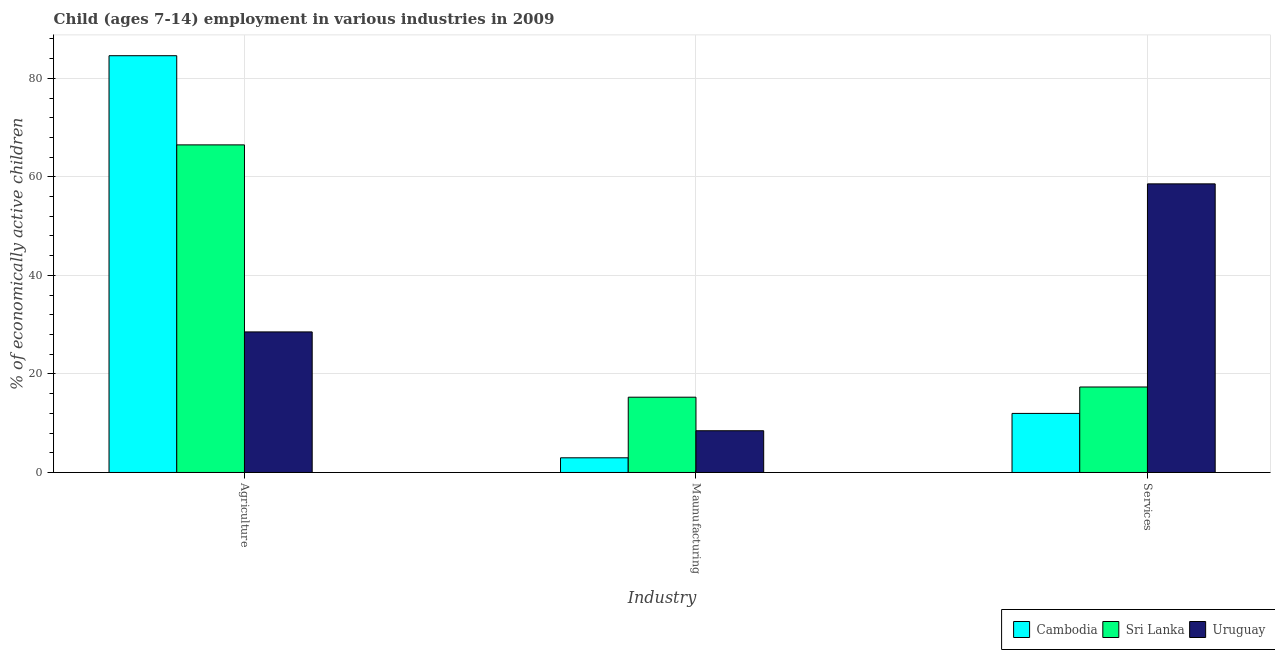How many different coloured bars are there?
Provide a succinct answer. 3. How many groups of bars are there?
Your response must be concise. 3. Are the number of bars per tick equal to the number of legend labels?
Your answer should be compact. Yes. What is the label of the 1st group of bars from the left?
Offer a terse response. Agriculture. What is the percentage of economically active children in agriculture in Cambodia?
Give a very brief answer. 84.59. Across all countries, what is the maximum percentage of economically active children in agriculture?
Your response must be concise. 84.59. Across all countries, what is the minimum percentage of economically active children in agriculture?
Provide a short and direct response. 28.53. In which country was the percentage of economically active children in agriculture maximum?
Make the answer very short. Cambodia. In which country was the percentage of economically active children in manufacturing minimum?
Provide a succinct answer. Cambodia. What is the total percentage of economically active children in manufacturing in the graph?
Your answer should be very brief. 26.73. What is the difference between the percentage of economically active children in manufacturing in Cambodia and that in Uruguay?
Your answer should be compact. -5.49. What is the difference between the percentage of economically active children in agriculture in Uruguay and the percentage of economically active children in services in Sri Lanka?
Keep it short and to the point. 11.18. What is the average percentage of economically active children in manufacturing per country?
Make the answer very short. 8.91. What is the difference between the percentage of economically active children in manufacturing and percentage of economically active children in services in Cambodia?
Your answer should be very brief. -9.01. In how many countries, is the percentage of economically active children in agriculture greater than 60 %?
Offer a terse response. 2. What is the ratio of the percentage of economically active children in services in Uruguay to that in Sri Lanka?
Make the answer very short. 3.38. What is the difference between the highest and the second highest percentage of economically active children in manufacturing?
Provide a succinct answer. 6.81. What is the difference between the highest and the lowest percentage of economically active children in services?
Give a very brief answer. 46.59. In how many countries, is the percentage of economically active children in manufacturing greater than the average percentage of economically active children in manufacturing taken over all countries?
Provide a short and direct response. 1. Is the sum of the percentage of economically active children in agriculture in Uruguay and Sri Lanka greater than the maximum percentage of economically active children in services across all countries?
Your answer should be very brief. Yes. What does the 2nd bar from the left in Services represents?
Your answer should be very brief. Sri Lanka. What does the 3rd bar from the right in Agriculture represents?
Make the answer very short. Cambodia. How many bars are there?
Offer a terse response. 9. Are all the bars in the graph horizontal?
Provide a short and direct response. No. How many countries are there in the graph?
Provide a short and direct response. 3. What is the difference between two consecutive major ticks on the Y-axis?
Ensure brevity in your answer.  20. How are the legend labels stacked?
Offer a terse response. Horizontal. What is the title of the graph?
Give a very brief answer. Child (ages 7-14) employment in various industries in 2009. What is the label or title of the X-axis?
Your response must be concise. Industry. What is the label or title of the Y-axis?
Your answer should be compact. % of economically active children. What is the % of economically active children in Cambodia in Agriculture?
Ensure brevity in your answer.  84.59. What is the % of economically active children of Sri Lanka in Agriculture?
Provide a short and direct response. 66.49. What is the % of economically active children of Uruguay in Agriculture?
Make the answer very short. 28.53. What is the % of economically active children in Cambodia in Maunufacturing?
Keep it short and to the point. 2.98. What is the % of economically active children in Sri Lanka in Maunufacturing?
Give a very brief answer. 15.28. What is the % of economically active children in Uruguay in Maunufacturing?
Make the answer very short. 8.47. What is the % of economically active children in Cambodia in Services?
Provide a succinct answer. 11.99. What is the % of economically active children in Sri Lanka in Services?
Keep it short and to the point. 17.35. What is the % of economically active children in Uruguay in Services?
Your answer should be compact. 58.58. Across all Industry, what is the maximum % of economically active children of Cambodia?
Keep it short and to the point. 84.59. Across all Industry, what is the maximum % of economically active children in Sri Lanka?
Your answer should be compact. 66.49. Across all Industry, what is the maximum % of economically active children in Uruguay?
Your answer should be very brief. 58.58. Across all Industry, what is the minimum % of economically active children of Cambodia?
Your answer should be compact. 2.98. Across all Industry, what is the minimum % of economically active children of Sri Lanka?
Your answer should be very brief. 15.28. Across all Industry, what is the minimum % of economically active children in Uruguay?
Your response must be concise. 8.47. What is the total % of economically active children in Cambodia in the graph?
Keep it short and to the point. 99.56. What is the total % of economically active children of Sri Lanka in the graph?
Keep it short and to the point. 99.12. What is the total % of economically active children in Uruguay in the graph?
Keep it short and to the point. 95.58. What is the difference between the % of economically active children in Cambodia in Agriculture and that in Maunufacturing?
Ensure brevity in your answer.  81.61. What is the difference between the % of economically active children of Sri Lanka in Agriculture and that in Maunufacturing?
Offer a very short reply. 51.21. What is the difference between the % of economically active children in Uruguay in Agriculture and that in Maunufacturing?
Provide a short and direct response. 20.06. What is the difference between the % of economically active children of Cambodia in Agriculture and that in Services?
Your answer should be very brief. 72.6. What is the difference between the % of economically active children of Sri Lanka in Agriculture and that in Services?
Ensure brevity in your answer.  49.14. What is the difference between the % of economically active children of Uruguay in Agriculture and that in Services?
Your answer should be very brief. -30.05. What is the difference between the % of economically active children in Cambodia in Maunufacturing and that in Services?
Provide a succinct answer. -9.01. What is the difference between the % of economically active children of Sri Lanka in Maunufacturing and that in Services?
Give a very brief answer. -2.07. What is the difference between the % of economically active children of Uruguay in Maunufacturing and that in Services?
Ensure brevity in your answer.  -50.11. What is the difference between the % of economically active children of Cambodia in Agriculture and the % of economically active children of Sri Lanka in Maunufacturing?
Make the answer very short. 69.31. What is the difference between the % of economically active children in Cambodia in Agriculture and the % of economically active children in Uruguay in Maunufacturing?
Your response must be concise. 76.12. What is the difference between the % of economically active children of Sri Lanka in Agriculture and the % of economically active children of Uruguay in Maunufacturing?
Offer a very short reply. 58.02. What is the difference between the % of economically active children of Cambodia in Agriculture and the % of economically active children of Sri Lanka in Services?
Your answer should be very brief. 67.24. What is the difference between the % of economically active children of Cambodia in Agriculture and the % of economically active children of Uruguay in Services?
Your response must be concise. 26.01. What is the difference between the % of economically active children of Sri Lanka in Agriculture and the % of economically active children of Uruguay in Services?
Your response must be concise. 7.91. What is the difference between the % of economically active children in Cambodia in Maunufacturing and the % of economically active children in Sri Lanka in Services?
Ensure brevity in your answer.  -14.37. What is the difference between the % of economically active children in Cambodia in Maunufacturing and the % of economically active children in Uruguay in Services?
Keep it short and to the point. -55.6. What is the difference between the % of economically active children of Sri Lanka in Maunufacturing and the % of economically active children of Uruguay in Services?
Ensure brevity in your answer.  -43.3. What is the average % of economically active children of Cambodia per Industry?
Your answer should be very brief. 33.19. What is the average % of economically active children of Sri Lanka per Industry?
Your response must be concise. 33.04. What is the average % of economically active children in Uruguay per Industry?
Give a very brief answer. 31.86. What is the difference between the % of economically active children of Cambodia and % of economically active children of Sri Lanka in Agriculture?
Your answer should be compact. 18.1. What is the difference between the % of economically active children in Cambodia and % of economically active children in Uruguay in Agriculture?
Keep it short and to the point. 56.06. What is the difference between the % of economically active children of Sri Lanka and % of economically active children of Uruguay in Agriculture?
Offer a very short reply. 37.96. What is the difference between the % of economically active children in Cambodia and % of economically active children in Sri Lanka in Maunufacturing?
Your answer should be very brief. -12.3. What is the difference between the % of economically active children of Cambodia and % of economically active children of Uruguay in Maunufacturing?
Make the answer very short. -5.49. What is the difference between the % of economically active children in Sri Lanka and % of economically active children in Uruguay in Maunufacturing?
Your answer should be very brief. 6.81. What is the difference between the % of economically active children in Cambodia and % of economically active children in Sri Lanka in Services?
Keep it short and to the point. -5.36. What is the difference between the % of economically active children of Cambodia and % of economically active children of Uruguay in Services?
Your response must be concise. -46.59. What is the difference between the % of economically active children of Sri Lanka and % of economically active children of Uruguay in Services?
Your response must be concise. -41.23. What is the ratio of the % of economically active children in Cambodia in Agriculture to that in Maunufacturing?
Your response must be concise. 28.39. What is the ratio of the % of economically active children of Sri Lanka in Agriculture to that in Maunufacturing?
Offer a terse response. 4.35. What is the ratio of the % of economically active children of Uruguay in Agriculture to that in Maunufacturing?
Make the answer very short. 3.37. What is the ratio of the % of economically active children in Cambodia in Agriculture to that in Services?
Your answer should be very brief. 7.05. What is the ratio of the % of economically active children of Sri Lanka in Agriculture to that in Services?
Your answer should be very brief. 3.83. What is the ratio of the % of economically active children of Uruguay in Agriculture to that in Services?
Your answer should be very brief. 0.49. What is the ratio of the % of economically active children in Cambodia in Maunufacturing to that in Services?
Your answer should be very brief. 0.25. What is the ratio of the % of economically active children in Sri Lanka in Maunufacturing to that in Services?
Offer a very short reply. 0.88. What is the ratio of the % of economically active children of Uruguay in Maunufacturing to that in Services?
Ensure brevity in your answer.  0.14. What is the difference between the highest and the second highest % of economically active children of Cambodia?
Give a very brief answer. 72.6. What is the difference between the highest and the second highest % of economically active children of Sri Lanka?
Make the answer very short. 49.14. What is the difference between the highest and the second highest % of economically active children of Uruguay?
Give a very brief answer. 30.05. What is the difference between the highest and the lowest % of economically active children of Cambodia?
Your answer should be compact. 81.61. What is the difference between the highest and the lowest % of economically active children in Sri Lanka?
Your answer should be very brief. 51.21. What is the difference between the highest and the lowest % of economically active children of Uruguay?
Offer a very short reply. 50.11. 